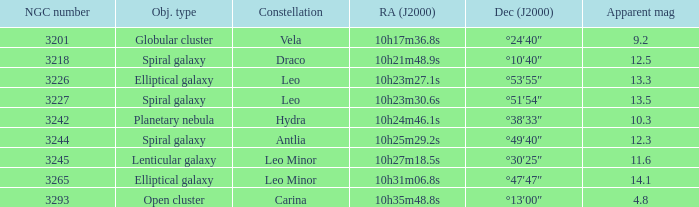What is the total of Apparent magnitudes for an NGC number larger than 3293? None. 